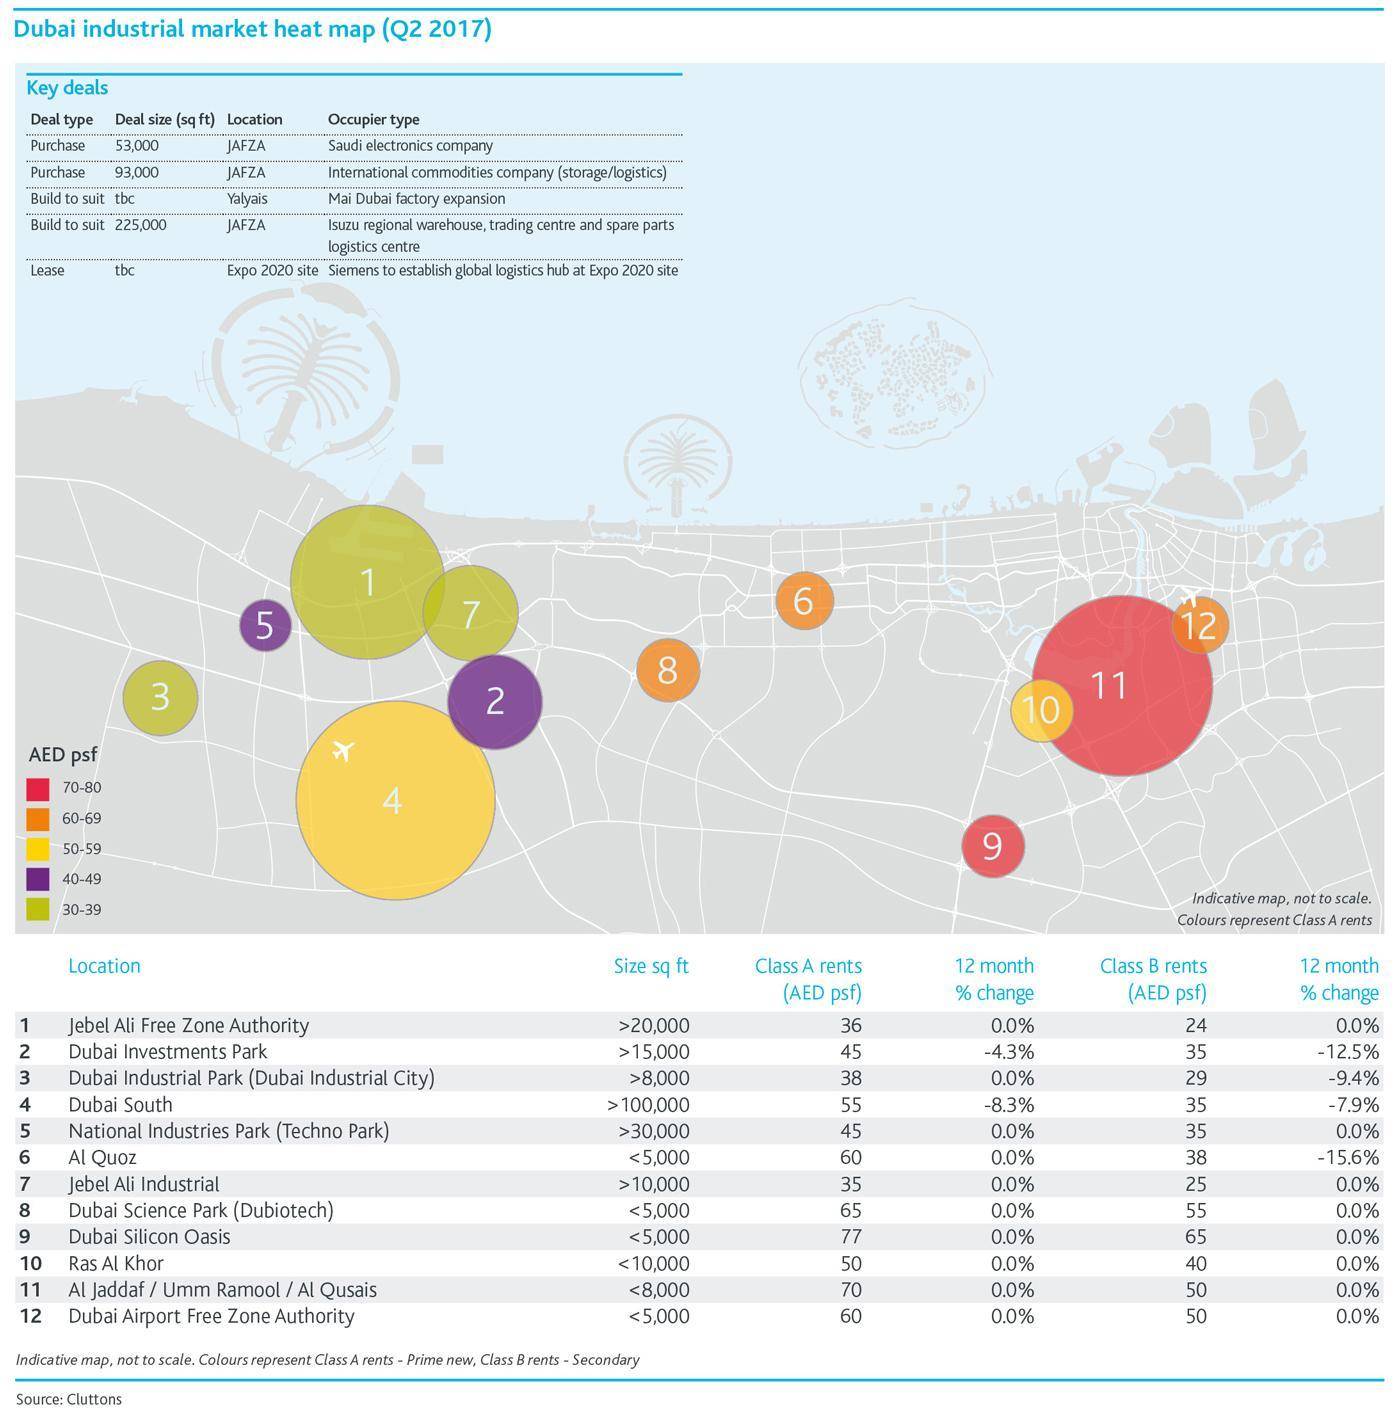How many location has Class A rents in the range 30-39?
Answer the question with a short phrase. 3 Which is the second item in the third row of the table Key Deals? tbc How many locations has square feet size greater than 20,000? 3 How much is the difference between the Class A rent and B rent of Al Quoz? 22 How many location has Class A rents in the range 50-59? 2 Which location has the second highest Class A Rent? Al Jadaff / Umm Ramool / Al Qusais How many locations has Square feet size greater than Dubai Industrial Park? 5 How much is the difference between the Class A rent and B rent of Dubai South? 20 Which are the locations where Class A rents are in the range 70-80? Dubai Silicon Oasis, Al Jadaff / Umm Ramool / Al Qusais How many key deals have Location as JAFZA? 3 